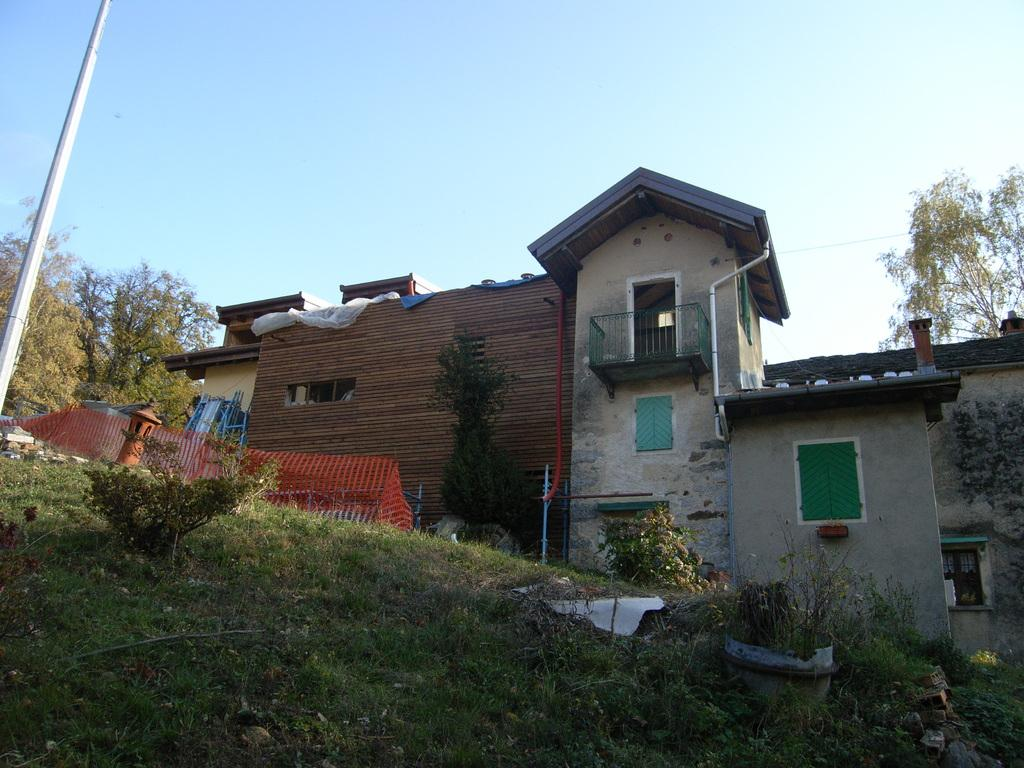What type of ground is visible in the image? There is a greenery ground in the image. What can be found on the ground? The ground has plants on it. What is the color of the fence in the image? There is a red color fence in the image. What is the tall, vertical structure in the image? There is a pole in the image. Where are the trees located in the image? There are trees in the left corner of the image. What can be seen in the background of the image? There is a building in the background of the image. What type of trade is happening in the image? There is no trade happening in the image; it is a scene with greenery, a fence, a pole, trees, and a building. What arithmetic problem can be solved using the numbers in the image? There are no numbers present in the image to solve an arithmetic problem. 